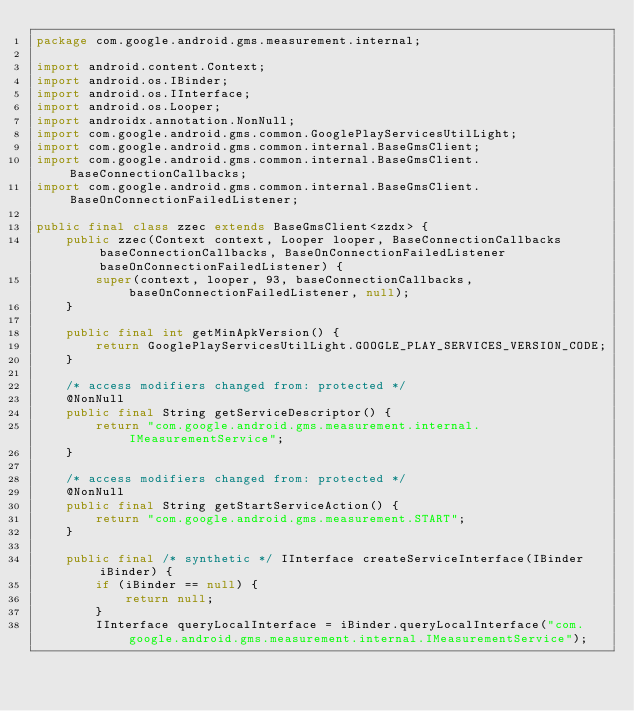Convert code to text. <code><loc_0><loc_0><loc_500><loc_500><_Java_>package com.google.android.gms.measurement.internal;

import android.content.Context;
import android.os.IBinder;
import android.os.IInterface;
import android.os.Looper;
import androidx.annotation.NonNull;
import com.google.android.gms.common.GooglePlayServicesUtilLight;
import com.google.android.gms.common.internal.BaseGmsClient;
import com.google.android.gms.common.internal.BaseGmsClient.BaseConnectionCallbacks;
import com.google.android.gms.common.internal.BaseGmsClient.BaseOnConnectionFailedListener;

public final class zzec extends BaseGmsClient<zzdx> {
    public zzec(Context context, Looper looper, BaseConnectionCallbacks baseConnectionCallbacks, BaseOnConnectionFailedListener baseOnConnectionFailedListener) {
        super(context, looper, 93, baseConnectionCallbacks, baseOnConnectionFailedListener, null);
    }

    public final int getMinApkVersion() {
        return GooglePlayServicesUtilLight.GOOGLE_PLAY_SERVICES_VERSION_CODE;
    }

    /* access modifiers changed from: protected */
    @NonNull
    public final String getServiceDescriptor() {
        return "com.google.android.gms.measurement.internal.IMeasurementService";
    }

    /* access modifiers changed from: protected */
    @NonNull
    public final String getStartServiceAction() {
        return "com.google.android.gms.measurement.START";
    }

    public final /* synthetic */ IInterface createServiceInterface(IBinder iBinder) {
        if (iBinder == null) {
            return null;
        }
        IInterface queryLocalInterface = iBinder.queryLocalInterface("com.google.android.gms.measurement.internal.IMeasurementService");</code> 